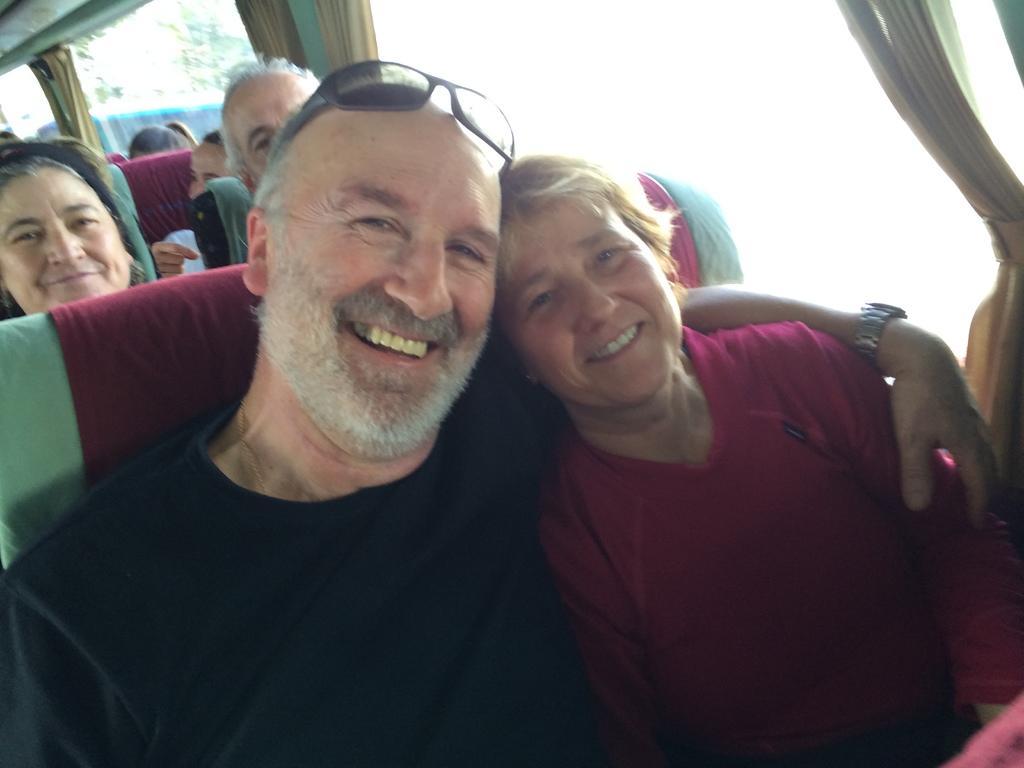Can you describe this image briefly? In the image there is a man with goggles on his head is sitting. Beside him there is a lady. Behind them there are few people sitting on seats. Beside them there are glass windows with curtains. 